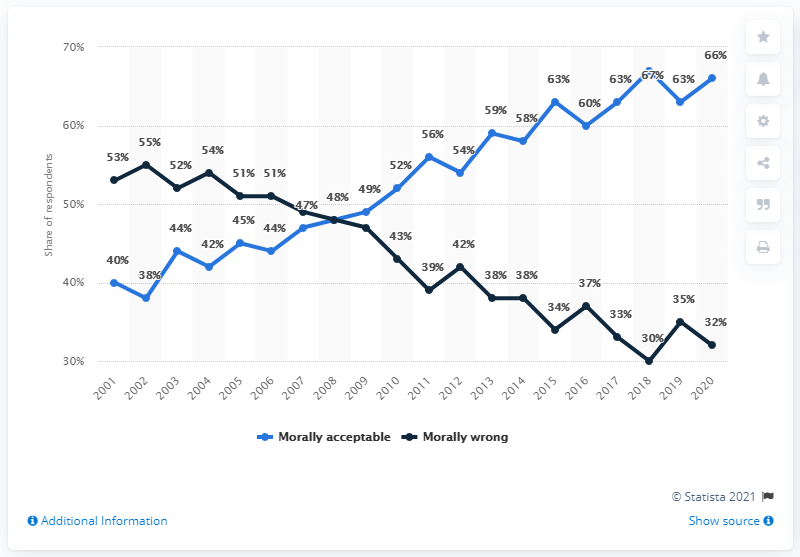Point out several critical features in this image. According to a survey conducted in 2015, 63% of respondents morally accepted gay or lesbian relationships. The difference between respondents who think gay or lesbian relationships are morally acceptable and those who think they are morally wrong is highest in 2020. 